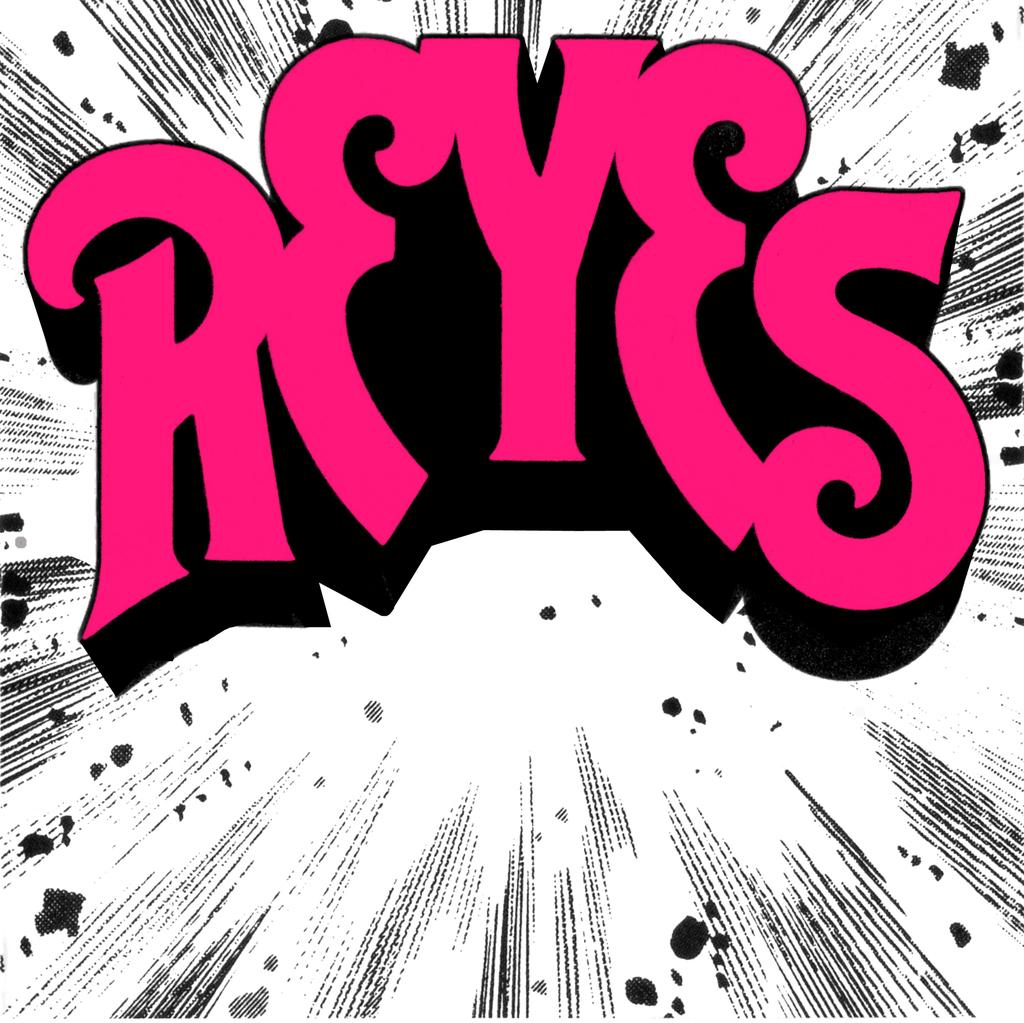What does the pink font say?
Provide a short and direct response. Reyes. 